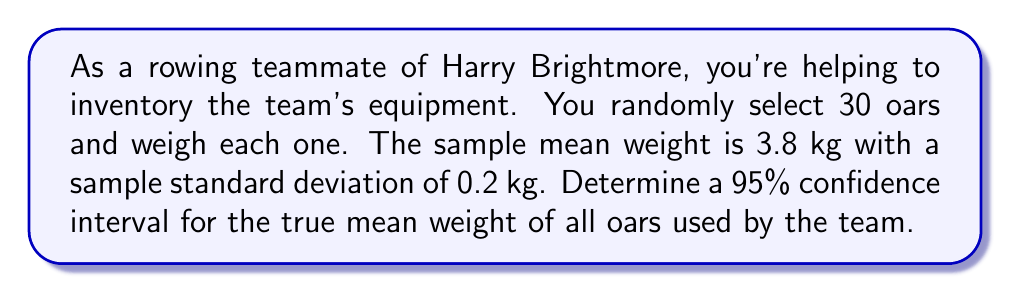Provide a solution to this math problem. To determine the confidence interval, we'll follow these steps:

1) We're dealing with a sample size of n = 30, which is large enough to use the normal distribution.

2) For a 95% confidence interval, we use a z-score of 1.96.

3) The formula for the confidence interval is:

   $$\bar{x} \pm z \cdot \frac{s}{\sqrt{n}}$$

   Where:
   $\bar{x}$ is the sample mean (3.8 kg)
   $z$ is the z-score (1.96 for 95% confidence)
   $s$ is the sample standard deviation (0.2 kg)
   $n$ is the sample size (30)

4) Let's substitute these values:

   $$3.8 \pm 1.96 \cdot \frac{0.2}{\sqrt{30}}$$

5) Simplify:
   $$3.8 \pm 1.96 \cdot \frac{0.2}{5.477}$$
   $$3.8 \pm 1.96 \cdot 0.0365$$
   $$3.8 \pm 0.0716$$

6) Calculate the lower and upper bounds:
   Lower bound: $3.8 - 0.0716 = 3.7284$
   Upper bound: $3.8 + 0.0716 = 3.8716$

7) Round to three decimal places:
   $$(3.728, 3.872)$$

Therefore, we can be 95% confident that the true mean weight of all oars used by the team falls between 3.728 kg and 3.872 kg.
Answer: (3.728 kg, 3.872 kg) 